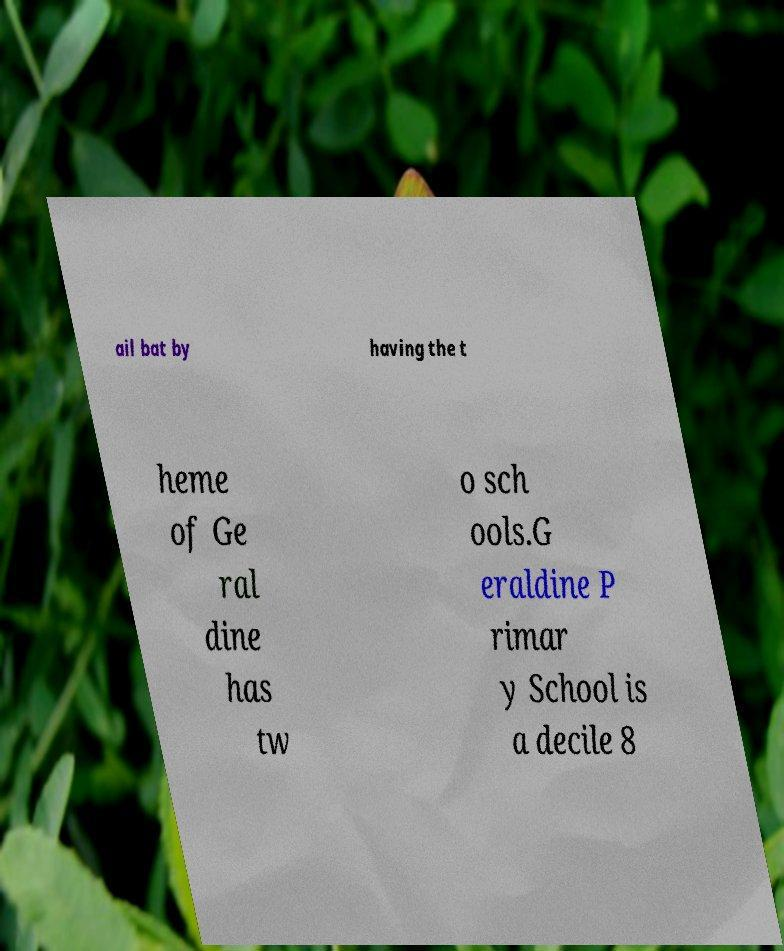I need the written content from this picture converted into text. Can you do that? ail bat by having the t heme of Ge ral dine has tw o sch ools.G eraldine P rimar y School is a decile 8 